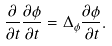Convert formula to latex. <formula><loc_0><loc_0><loc_500><loc_500>\frac { \partial } { \partial t } \frac { \partial \phi } { \partial t } = \Delta _ { \phi } \frac { \partial \phi } { \partial t } .</formula> 